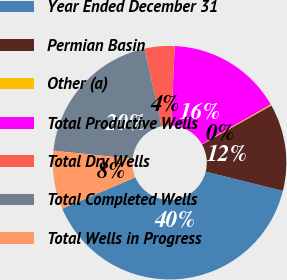<chart> <loc_0><loc_0><loc_500><loc_500><pie_chart><fcel>Year Ended December 31<fcel>Permian Basin<fcel>Other (a)<fcel>Total Productive Wells<fcel>Total Dry Wells<fcel>Total Completed Wells<fcel>Total Wells in Progress<nl><fcel>39.69%<fcel>12.03%<fcel>0.17%<fcel>15.98%<fcel>4.13%<fcel>19.93%<fcel>8.08%<nl></chart> 